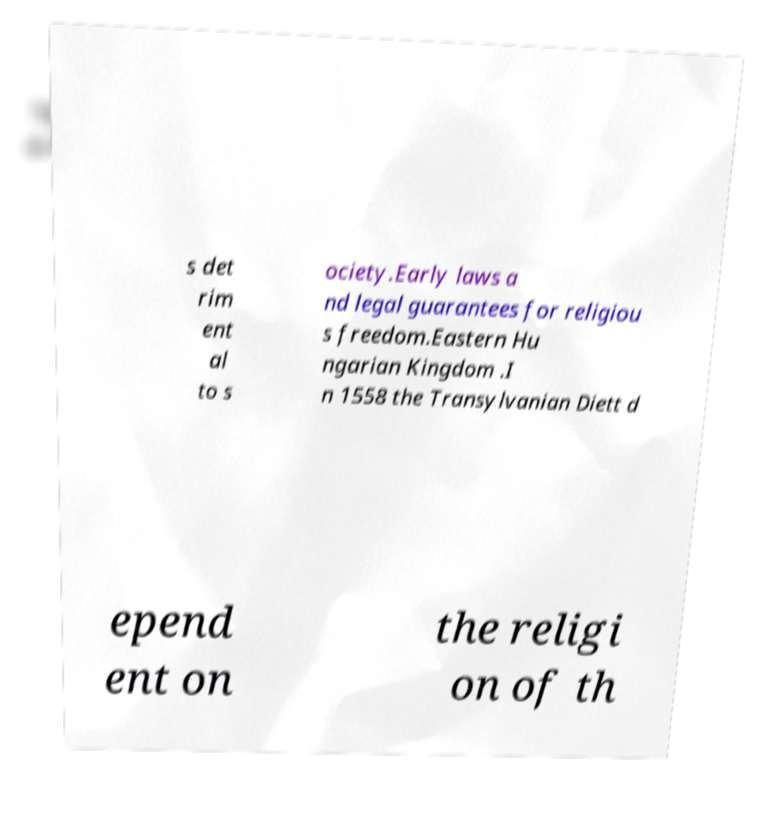Could you assist in decoding the text presented in this image and type it out clearly? s det rim ent al to s ociety.Early laws a nd legal guarantees for religiou s freedom.Eastern Hu ngarian Kingdom .I n 1558 the Transylvanian Diett d epend ent on the religi on of th 